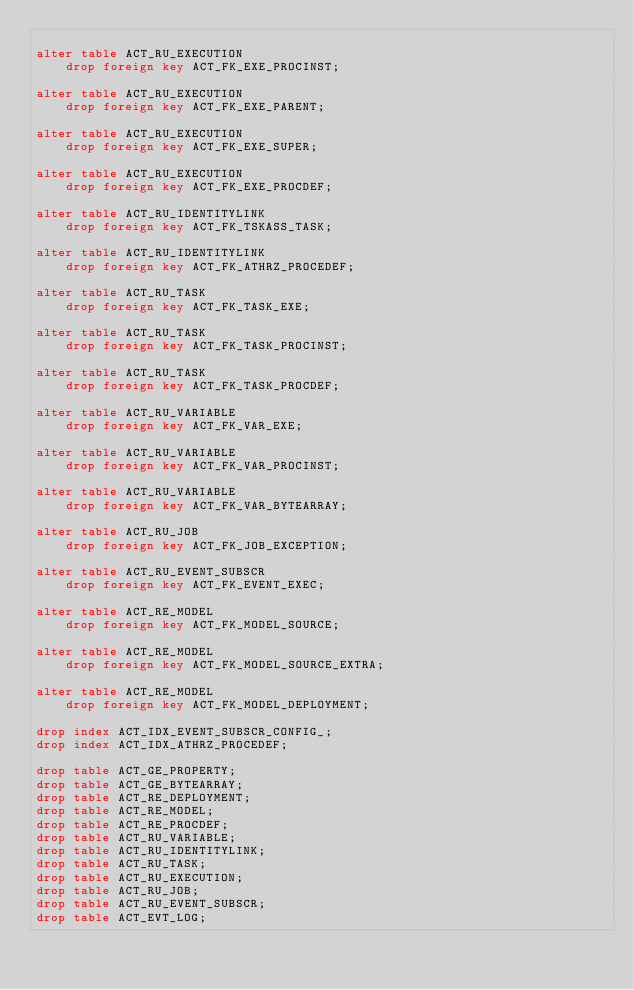<code> <loc_0><loc_0><loc_500><loc_500><_SQL_>
alter table ACT_RU_EXECUTION
    drop foreign key ACT_FK_EXE_PROCINST;

alter table ACT_RU_EXECUTION 
    drop foreign key ACT_FK_EXE_PARENT;

alter table ACT_RU_EXECUTION 
    drop foreign key ACT_FK_EXE_SUPER;
    
alter table ACT_RU_EXECUTION 
    drop foreign key ACT_FK_EXE_PROCDEF;

alter table ACT_RU_IDENTITYLINK
    drop foreign key ACT_FK_TSKASS_TASK;

alter table ACT_RU_IDENTITYLINK
    drop foreign key ACT_FK_ATHRZ_PROCEDEF;

alter table ACT_RU_TASK
	drop foreign key ACT_FK_TASK_EXE;

alter table ACT_RU_TASK
	drop foreign key ACT_FK_TASK_PROCINST;
	
alter table ACT_RU_TASK
	drop foreign key ACT_FK_TASK_PROCDEF;
    
alter table ACT_RU_VARIABLE
    drop foreign key ACT_FK_VAR_EXE;
    
alter table ACT_RU_VARIABLE
	drop foreign key ACT_FK_VAR_PROCINST;    

alter table ACT_RU_VARIABLE
    drop foreign key ACT_FK_VAR_BYTEARRAY;

alter table ACT_RU_JOB
    drop foreign key ACT_FK_JOB_EXCEPTION;
    
alter table ACT_RU_EVENT_SUBSCR
    drop foreign key ACT_FK_EVENT_EXEC;

alter table ACT_RE_MODEL 
    drop foreign key ACT_FK_MODEL_SOURCE;

alter table ACT_RE_MODEL 
    drop foreign key ACT_FK_MODEL_SOURCE_EXTRA; 
    
alter table ACT_RE_MODEL 
    drop foreign key ACT_FK_MODEL_DEPLOYMENT; 

drop index ACT_IDX_EVENT_SUBSCR_CONFIG_;
drop index ACT_IDX_ATHRZ_PROCEDEF;
    
drop table ACT_GE_PROPERTY;
drop table ACT_GE_BYTEARRAY;
drop table ACT_RE_DEPLOYMENT;
drop table ACT_RE_MODEL;
drop table ACT_RE_PROCDEF;
drop table ACT_RU_VARIABLE;
drop table ACT_RU_IDENTITYLINK;
drop table ACT_RU_TASK;
drop table ACT_RU_EXECUTION;
drop table ACT_RU_JOB;
drop table ACT_RU_EVENT_SUBSCR;
drop table ACT_EVT_LOG;
</code> 